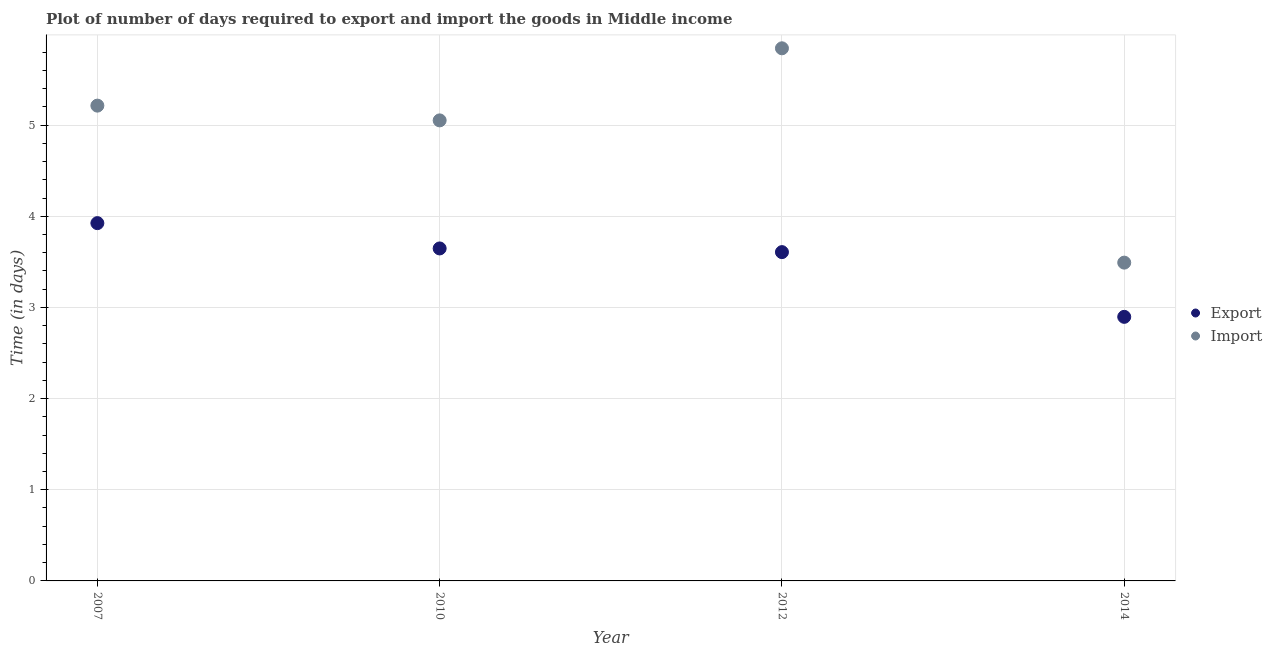How many different coloured dotlines are there?
Offer a terse response. 2. What is the time required to import in 2012?
Your response must be concise. 5.84. Across all years, what is the maximum time required to export?
Keep it short and to the point. 3.92. Across all years, what is the minimum time required to export?
Keep it short and to the point. 2.9. What is the total time required to export in the graph?
Your answer should be compact. 14.07. What is the difference between the time required to export in 2010 and that in 2014?
Provide a short and direct response. 0.75. What is the difference between the time required to import in 2010 and the time required to export in 2012?
Give a very brief answer. 1.44. What is the average time required to export per year?
Your answer should be very brief. 3.52. In the year 2007, what is the difference between the time required to export and time required to import?
Offer a very short reply. -1.29. What is the ratio of the time required to export in 2010 to that in 2012?
Ensure brevity in your answer.  1.01. Is the difference between the time required to import in 2010 and 2014 greater than the difference between the time required to export in 2010 and 2014?
Ensure brevity in your answer.  Yes. What is the difference between the highest and the second highest time required to export?
Offer a terse response. 0.28. What is the difference between the highest and the lowest time required to import?
Provide a succinct answer. 2.35. Is the time required to export strictly less than the time required to import over the years?
Your answer should be compact. Yes. How many dotlines are there?
Provide a succinct answer. 2. What is the difference between two consecutive major ticks on the Y-axis?
Offer a very short reply. 1. Are the values on the major ticks of Y-axis written in scientific E-notation?
Keep it short and to the point. No. Does the graph contain grids?
Your response must be concise. Yes. Where does the legend appear in the graph?
Offer a very short reply. Center right. How many legend labels are there?
Your answer should be compact. 2. What is the title of the graph?
Provide a short and direct response. Plot of number of days required to export and import the goods in Middle income. What is the label or title of the Y-axis?
Offer a very short reply. Time (in days). What is the Time (in days) in Export in 2007?
Keep it short and to the point. 3.92. What is the Time (in days) of Import in 2007?
Offer a terse response. 5.21. What is the Time (in days) in Export in 2010?
Give a very brief answer. 3.65. What is the Time (in days) of Import in 2010?
Provide a succinct answer. 5.05. What is the Time (in days) in Export in 2012?
Make the answer very short. 3.61. What is the Time (in days) in Import in 2012?
Keep it short and to the point. 5.84. What is the Time (in days) in Export in 2014?
Provide a short and direct response. 2.9. What is the Time (in days) in Import in 2014?
Keep it short and to the point. 3.49. Across all years, what is the maximum Time (in days) of Export?
Your answer should be compact. 3.92. Across all years, what is the maximum Time (in days) in Import?
Provide a short and direct response. 5.84. Across all years, what is the minimum Time (in days) in Export?
Provide a succinct answer. 2.9. Across all years, what is the minimum Time (in days) of Import?
Ensure brevity in your answer.  3.49. What is the total Time (in days) in Export in the graph?
Provide a succinct answer. 14.07. What is the total Time (in days) of Import in the graph?
Your answer should be very brief. 19.6. What is the difference between the Time (in days) of Export in 2007 and that in 2010?
Provide a short and direct response. 0.28. What is the difference between the Time (in days) in Import in 2007 and that in 2010?
Offer a very short reply. 0.16. What is the difference between the Time (in days) in Export in 2007 and that in 2012?
Ensure brevity in your answer.  0.32. What is the difference between the Time (in days) of Import in 2007 and that in 2012?
Your answer should be very brief. -0.63. What is the difference between the Time (in days) of Export in 2007 and that in 2014?
Your answer should be compact. 1.03. What is the difference between the Time (in days) of Import in 2007 and that in 2014?
Keep it short and to the point. 1.72. What is the difference between the Time (in days) in Export in 2010 and that in 2012?
Provide a short and direct response. 0.04. What is the difference between the Time (in days) in Import in 2010 and that in 2012?
Provide a succinct answer. -0.79. What is the difference between the Time (in days) of Export in 2010 and that in 2014?
Your answer should be compact. 0.75. What is the difference between the Time (in days) in Import in 2010 and that in 2014?
Your answer should be compact. 1.56. What is the difference between the Time (in days) in Export in 2012 and that in 2014?
Your response must be concise. 0.71. What is the difference between the Time (in days) of Import in 2012 and that in 2014?
Ensure brevity in your answer.  2.35. What is the difference between the Time (in days) of Export in 2007 and the Time (in days) of Import in 2010?
Offer a terse response. -1.13. What is the difference between the Time (in days) of Export in 2007 and the Time (in days) of Import in 2012?
Make the answer very short. -1.92. What is the difference between the Time (in days) in Export in 2007 and the Time (in days) in Import in 2014?
Your answer should be very brief. 0.43. What is the difference between the Time (in days) in Export in 2010 and the Time (in days) in Import in 2012?
Give a very brief answer. -2.2. What is the difference between the Time (in days) in Export in 2010 and the Time (in days) in Import in 2014?
Ensure brevity in your answer.  0.16. What is the difference between the Time (in days) in Export in 2012 and the Time (in days) in Import in 2014?
Your answer should be compact. 0.12. What is the average Time (in days) of Export per year?
Offer a very short reply. 3.52. What is the average Time (in days) in Import per year?
Ensure brevity in your answer.  4.9. In the year 2007, what is the difference between the Time (in days) of Export and Time (in days) of Import?
Your answer should be compact. -1.29. In the year 2010, what is the difference between the Time (in days) of Export and Time (in days) of Import?
Offer a very short reply. -1.4. In the year 2012, what is the difference between the Time (in days) in Export and Time (in days) in Import?
Offer a very short reply. -2.24. In the year 2014, what is the difference between the Time (in days) in Export and Time (in days) in Import?
Your answer should be very brief. -0.59. What is the ratio of the Time (in days) of Export in 2007 to that in 2010?
Provide a succinct answer. 1.08. What is the ratio of the Time (in days) of Import in 2007 to that in 2010?
Make the answer very short. 1.03. What is the ratio of the Time (in days) of Export in 2007 to that in 2012?
Make the answer very short. 1.09. What is the ratio of the Time (in days) in Import in 2007 to that in 2012?
Offer a terse response. 0.89. What is the ratio of the Time (in days) of Export in 2007 to that in 2014?
Your answer should be compact. 1.35. What is the ratio of the Time (in days) of Import in 2007 to that in 2014?
Provide a short and direct response. 1.49. What is the ratio of the Time (in days) of Export in 2010 to that in 2012?
Your answer should be very brief. 1.01. What is the ratio of the Time (in days) of Import in 2010 to that in 2012?
Your response must be concise. 0.86. What is the ratio of the Time (in days) in Export in 2010 to that in 2014?
Provide a succinct answer. 1.26. What is the ratio of the Time (in days) in Import in 2010 to that in 2014?
Ensure brevity in your answer.  1.45. What is the ratio of the Time (in days) of Export in 2012 to that in 2014?
Make the answer very short. 1.25. What is the ratio of the Time (in days) of Import in 2012 to that in 2014?
Provide a short and direct response. 1.67. What is the difference between the highest and the second highest Time (in days) of Export?
Ensure brevity in your answer.  0.28. What is the difference between the highest and the second highest Time (in days) in Import?
Keep it short and to the point. 0.63. What is the difference between the highest and the lowest Time (in days) of Export?
Offer a terse response. 1.03. What is the difference between the highest and the lowest Time (in days) of Import?
Your answer should be compact. 2.35. 